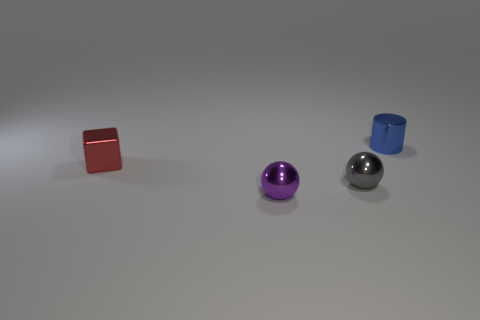Add 4 purple things. How many objects exist? 8 Add 3 small purple things. How many small purple things exist? 4 Subtract 0 cyan cubes. How many objects are left? 4 Subtract all cubes. How many objects are left? 3 Subtract all large purple objects. Subtract all tiny blue things. How many objects are left? 3 Add 1 purple shiny spheres. How many purple shiny spheres are left? 2 